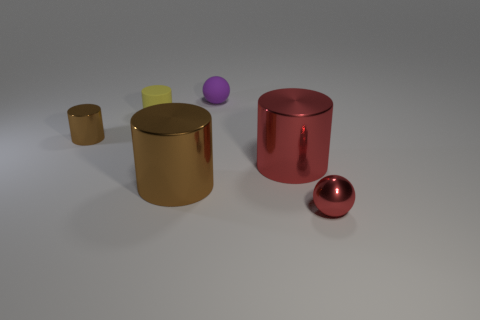Do the big metallic cylinder that is on the right side of the large brown shiny cylinder and the shiny ball have the same color?
Offer a terse response. Yes. Is there a cylinder of the same color as the small metal sphere?
Offer a very short reply. Yes. There is a cylinder that is both to the left of the purple rubber object and in front of the tiny brown object; what is its color?
Give a very brief answer. Brown. Are there fewer large brown cylinders that are behind the big brown metal cylinder than small matte spheres on the right side of the red shiny cylinder?
Your response must be concise. No. Is there any other thing that is the same color as the small shiny ball?
Make the answer very short. Yes. What is the shape of the yellow thing?
Ensure brevity in your answer.  Cylinder. There is a cylinder that is the same material as the purple sphere; what is its color?
Provide a short and direct response. Yellow. Are there more large purple metal things than large things?
Your answer should be very brief. No. Are there any yellow metallic spheres?
Offer a very short reply. No. There is a tiny thing in front of the object that is left of the small matte cylinder; what is its shape?
Your answer should be compact. Sphere. 